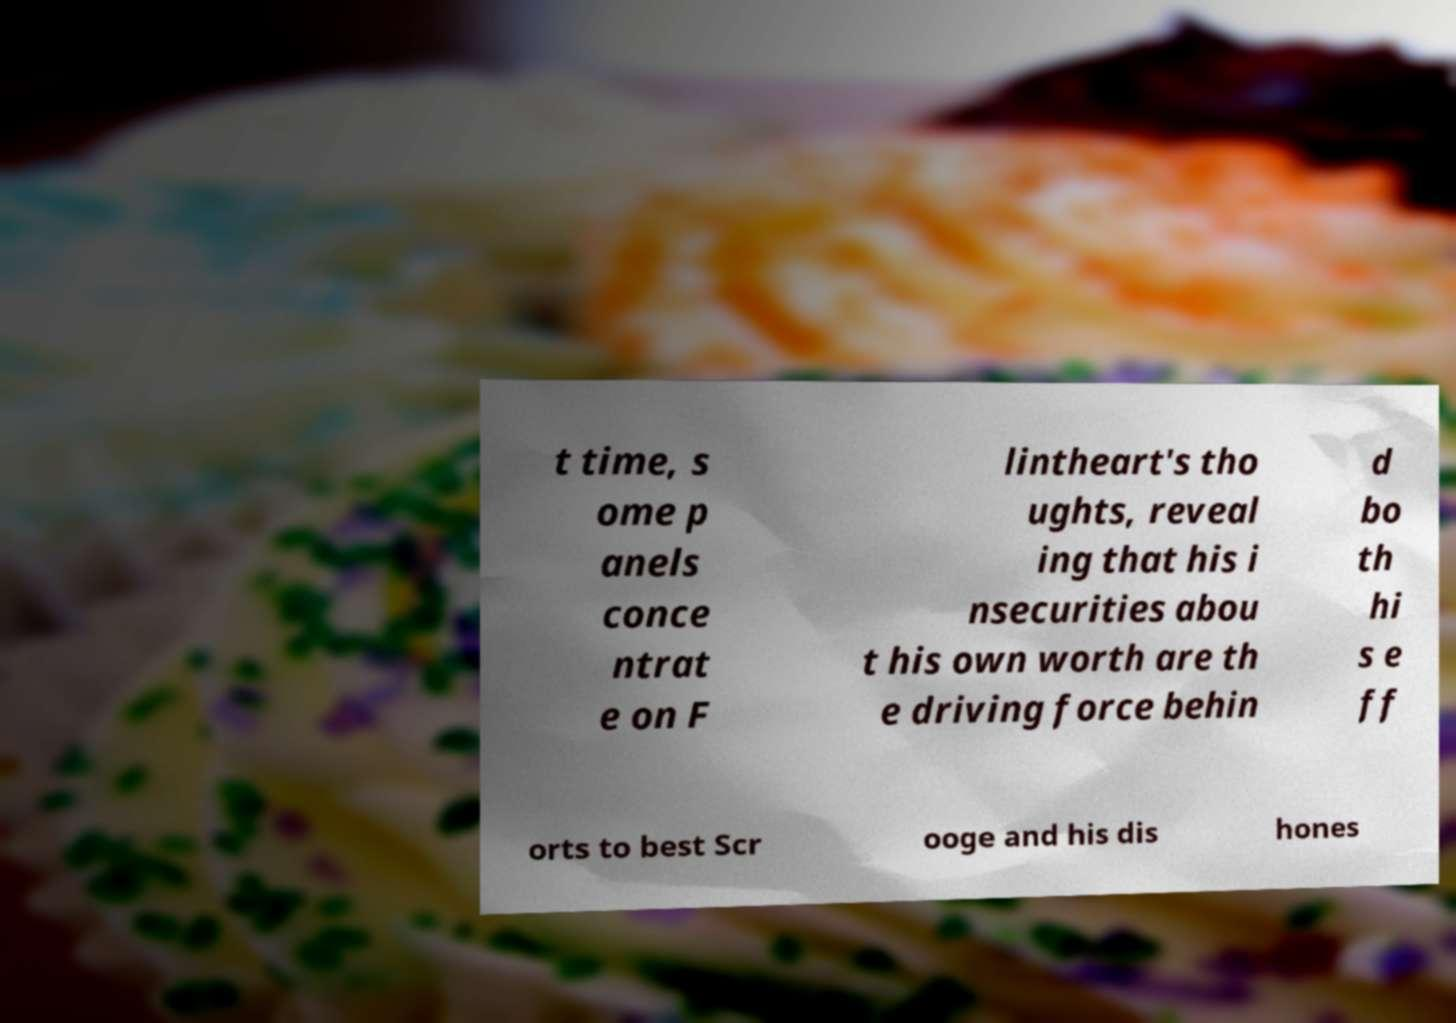There's text embedded in this image that I need extracted. Can you transcribe it verbatim? t time, s ome p anels conce ntrat e on F lintheart's tho ughts, reveal ing that his i nsecurities abou t his own worth are th e driving force behin d bo th hi s e ff orts to best Scr ooge and his dis hones 